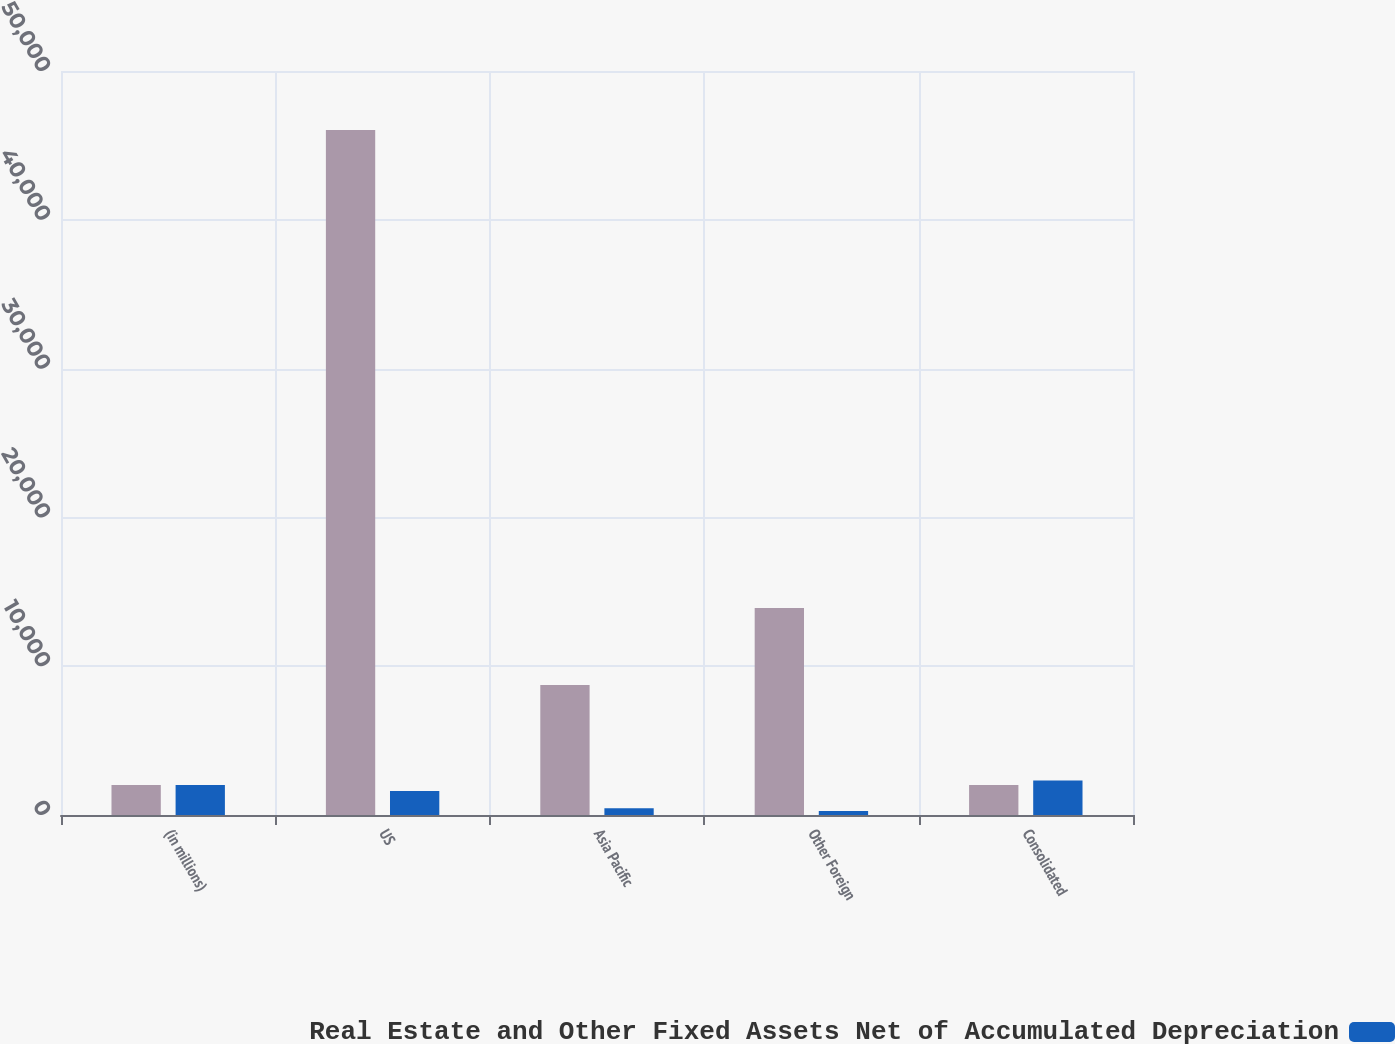Convert chart. <chart><loc_0><loc_0><loc_500><loc_500><stacked_bar_chart><ecel><fcel>(in millions)<fcel>US<fcel>Asia Pacific<fcel>Other Foreign<fcel>Consolidated<nl><fcel>nan<fcel>2013<fcel>46031<fcel>8742<fcel>13905<fcel>2013<nl><fcel>Real Estate and Other Fixed Assets Net of Accumulated Depreciation<fcel>2013<fcel>1606<fcel>448<fcel>261<fcel>2315<nl></chart> 